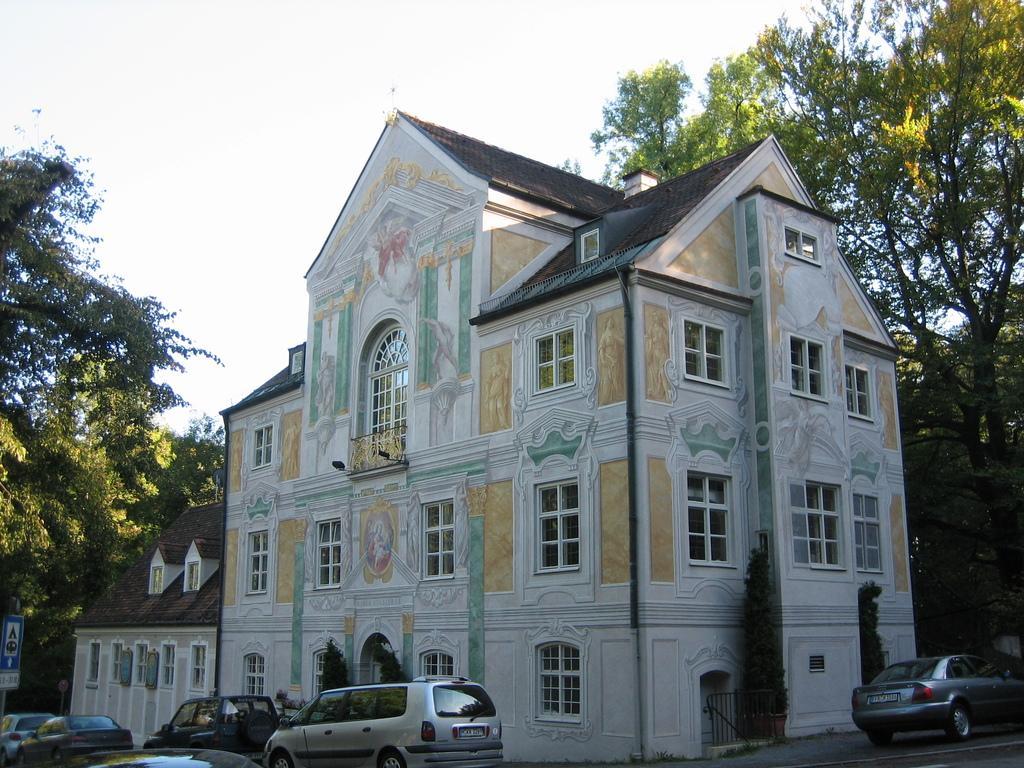Could you give a brief overview of what you see in this image? In this picture I can see there is a building, it has few cars parked in front of the building and beside the building. In the backdrop, there are few trees and the sky is clear. 